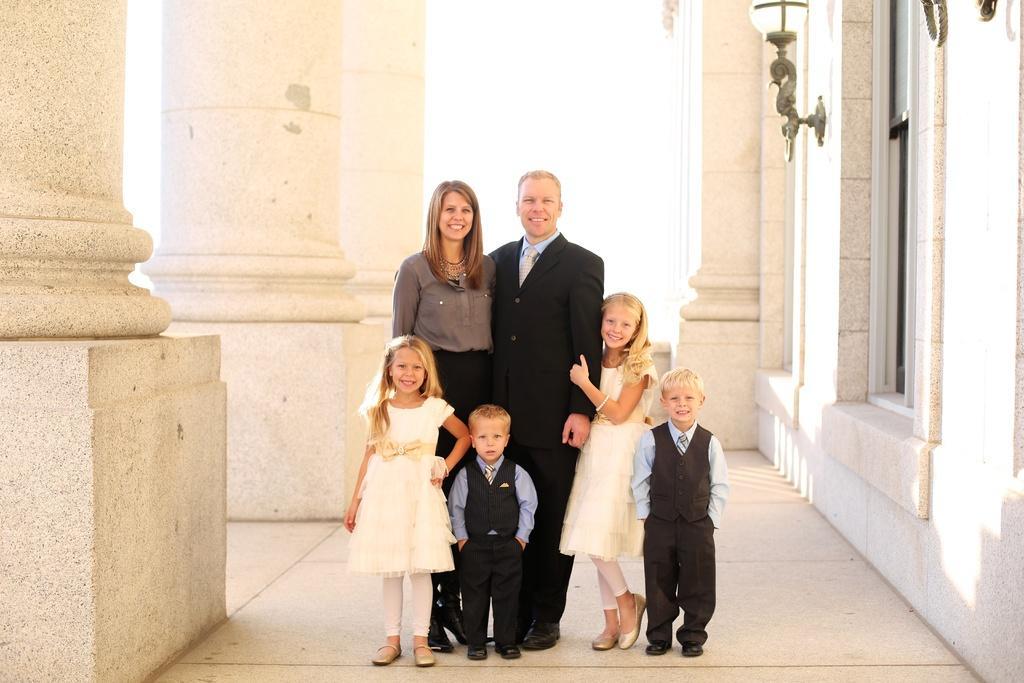In one or two sentences, can you explain what this image depicts? In the image there is a man, a woman and four children standing and posing for the photo and around them there are pillars, walls, lamp and a window. 